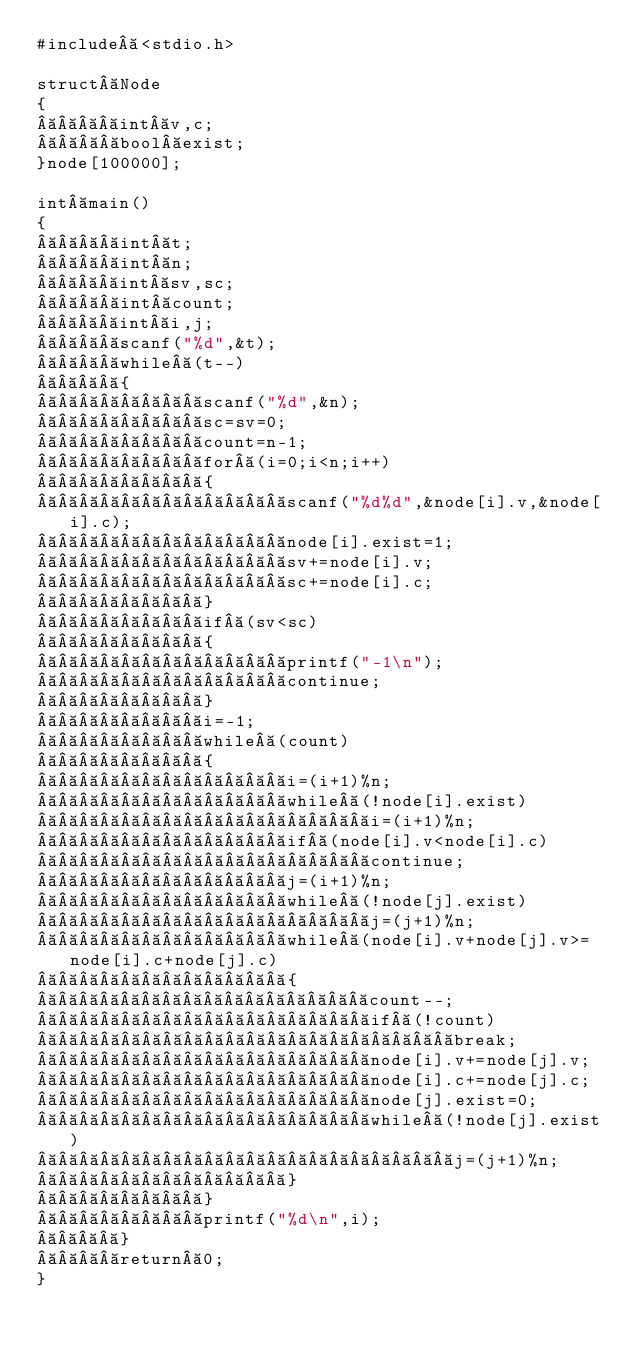Convert code to text. <code><loc_0><loc_0><loc_500><loc_500><_C++_>#include <stdio.h>

struct Node
{
    int v,c;
    bool exist;
}node[100000];

int main()
{
    int t;
    int n;
    int sv,sc;
    int count;
    int i,j;
    scanf("%d",&t);
    while (t--)
    {
        scanf("%d",&n);
        sc=sv=0;
        count=n-1;
        for (i=0;i<n;i++)
        {
            scanf("%d%d",&node[i].v,&node[i].c);
            node[i].exist=1;
            sv+=node[i].v;
            sc+=node[i].c;
        }
        if (sv<sc)
        {
            printf("-1\n");
            continue;
        }
        i=-1;
        while (count)
        {
            i=(i+1)%n;
            while (!node[i].exist)
                i=(i+1)%n;
            if (node[i].v<node[i].c)
                continue;
            j=(i+1)%n;
            while (!node[j].exist)
                j=(j+1)%n;
            while (node[i].v+node[j].v>=node[i].c+node[j].c)
            {
                count--;
                if (!count)
                    break;
                node[i].v+=node[j].v;
                node[i].c+=node[j].c;
                node[j].exist=0;
                while (!node[j].exist)
                    j=(j+1)%n;
            }
        }
        printf("%d\n",i);
    }
    return 0;
}</code> 